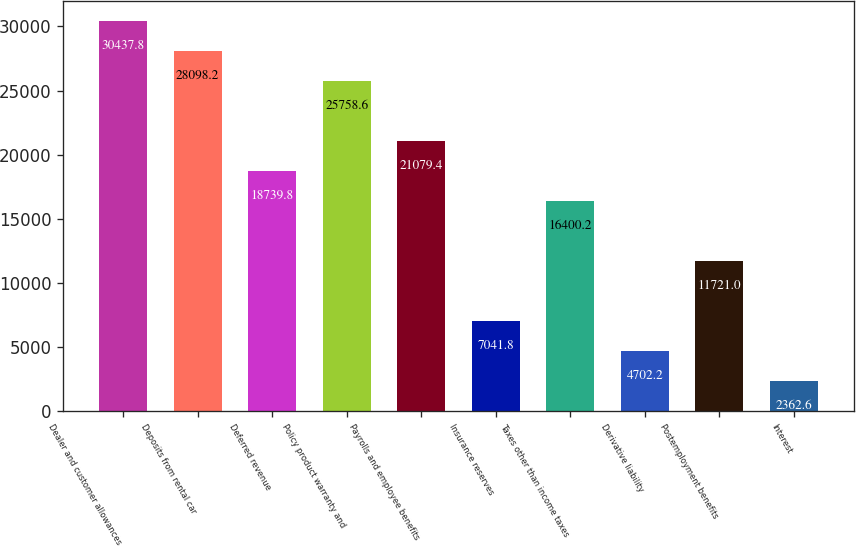Convert chart to OTSL. <chart><loc_0><loc_0><loc_500><loc_500><bar_chart><fcel>Dealer and customer allowances<fcel>Deposits from rental car<fcel>Deferred revenue<fcel>Policy product warranty and<fcel>Payrolls and employee benefits<fcel>Insurance reserves<fcel>Taxes other than income taxes<fcel>Derivative liability<fcel>Postemployment benefits<fcel>Interest<nl><fcel>30437.8<fcel>28098.2<fcel>18739.8<fcel>25758.6<fcel>21079.4<fcel>7041.8<fcel>16400.2<fcel>4702.2<fcel>11721<fcel>2362.6<nl></chart> 